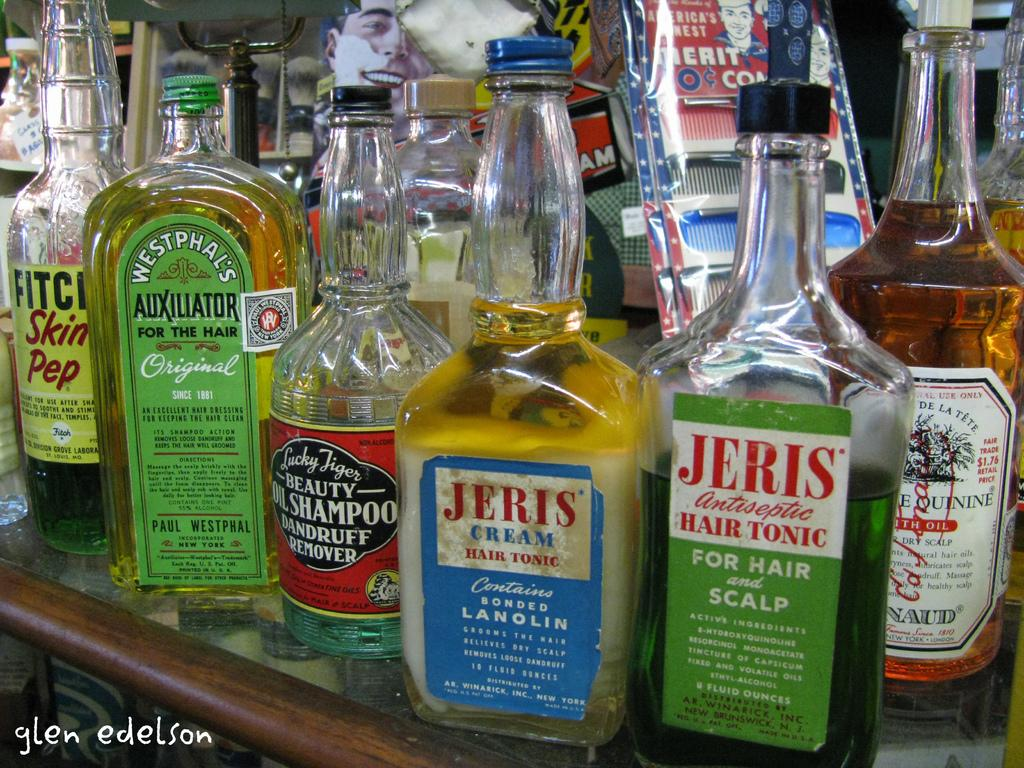<image>
Give a short and clear explanation of the subsequent image. Two bottles of Jeris hair products sit on a table crowded with bottles. 